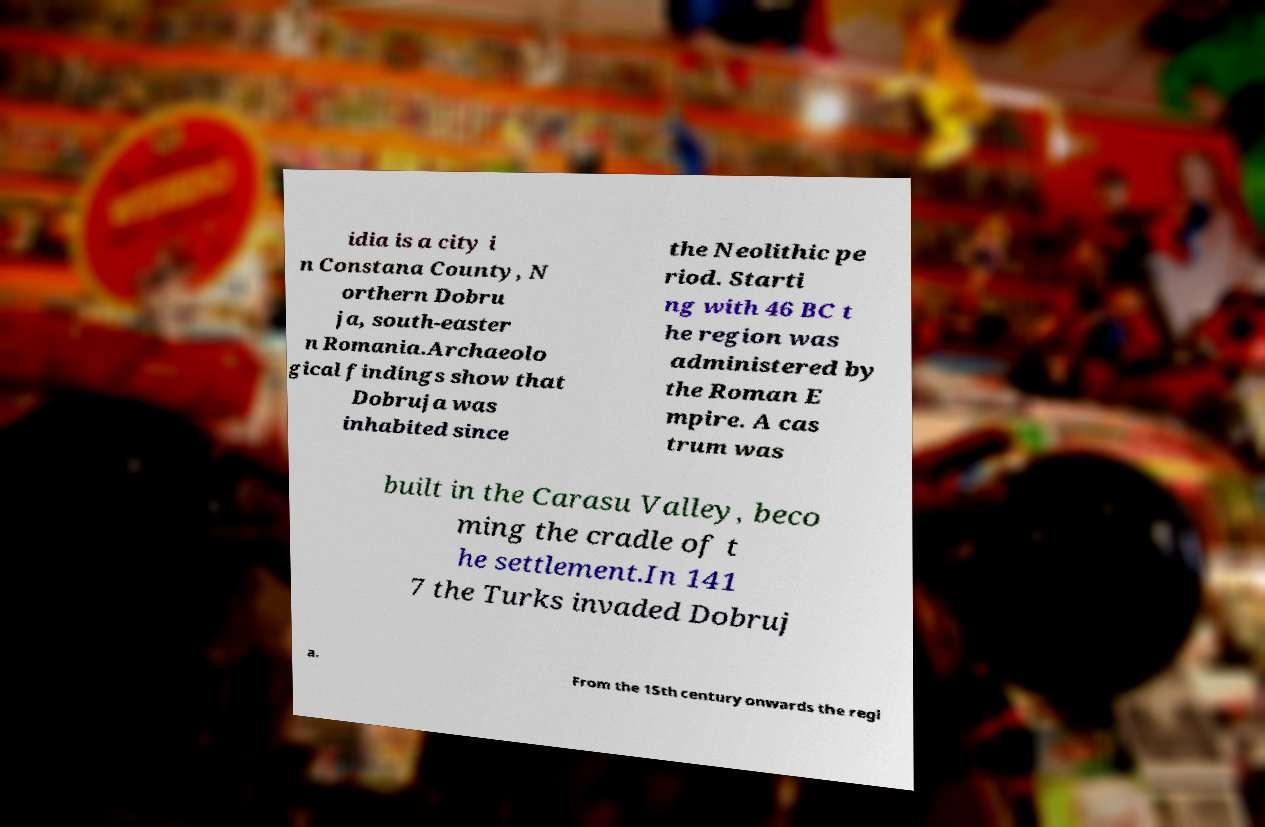Could you extract and type out the text from this image? idia is a city i n Constana County, N orthern Dobru ja, south-easter n Romania.Archaeolo gical findings show that Dobruja was inhabited since the Neolithic pe riod. Starti ng with 46 BC t he region was administered by the Roman E mpire. A cas trum was built in the Carasu Valley, beco ming the cradle of t he settlement.In 141 7 the Turks invaded Dobruj a. From the 15th century onwards the regi 